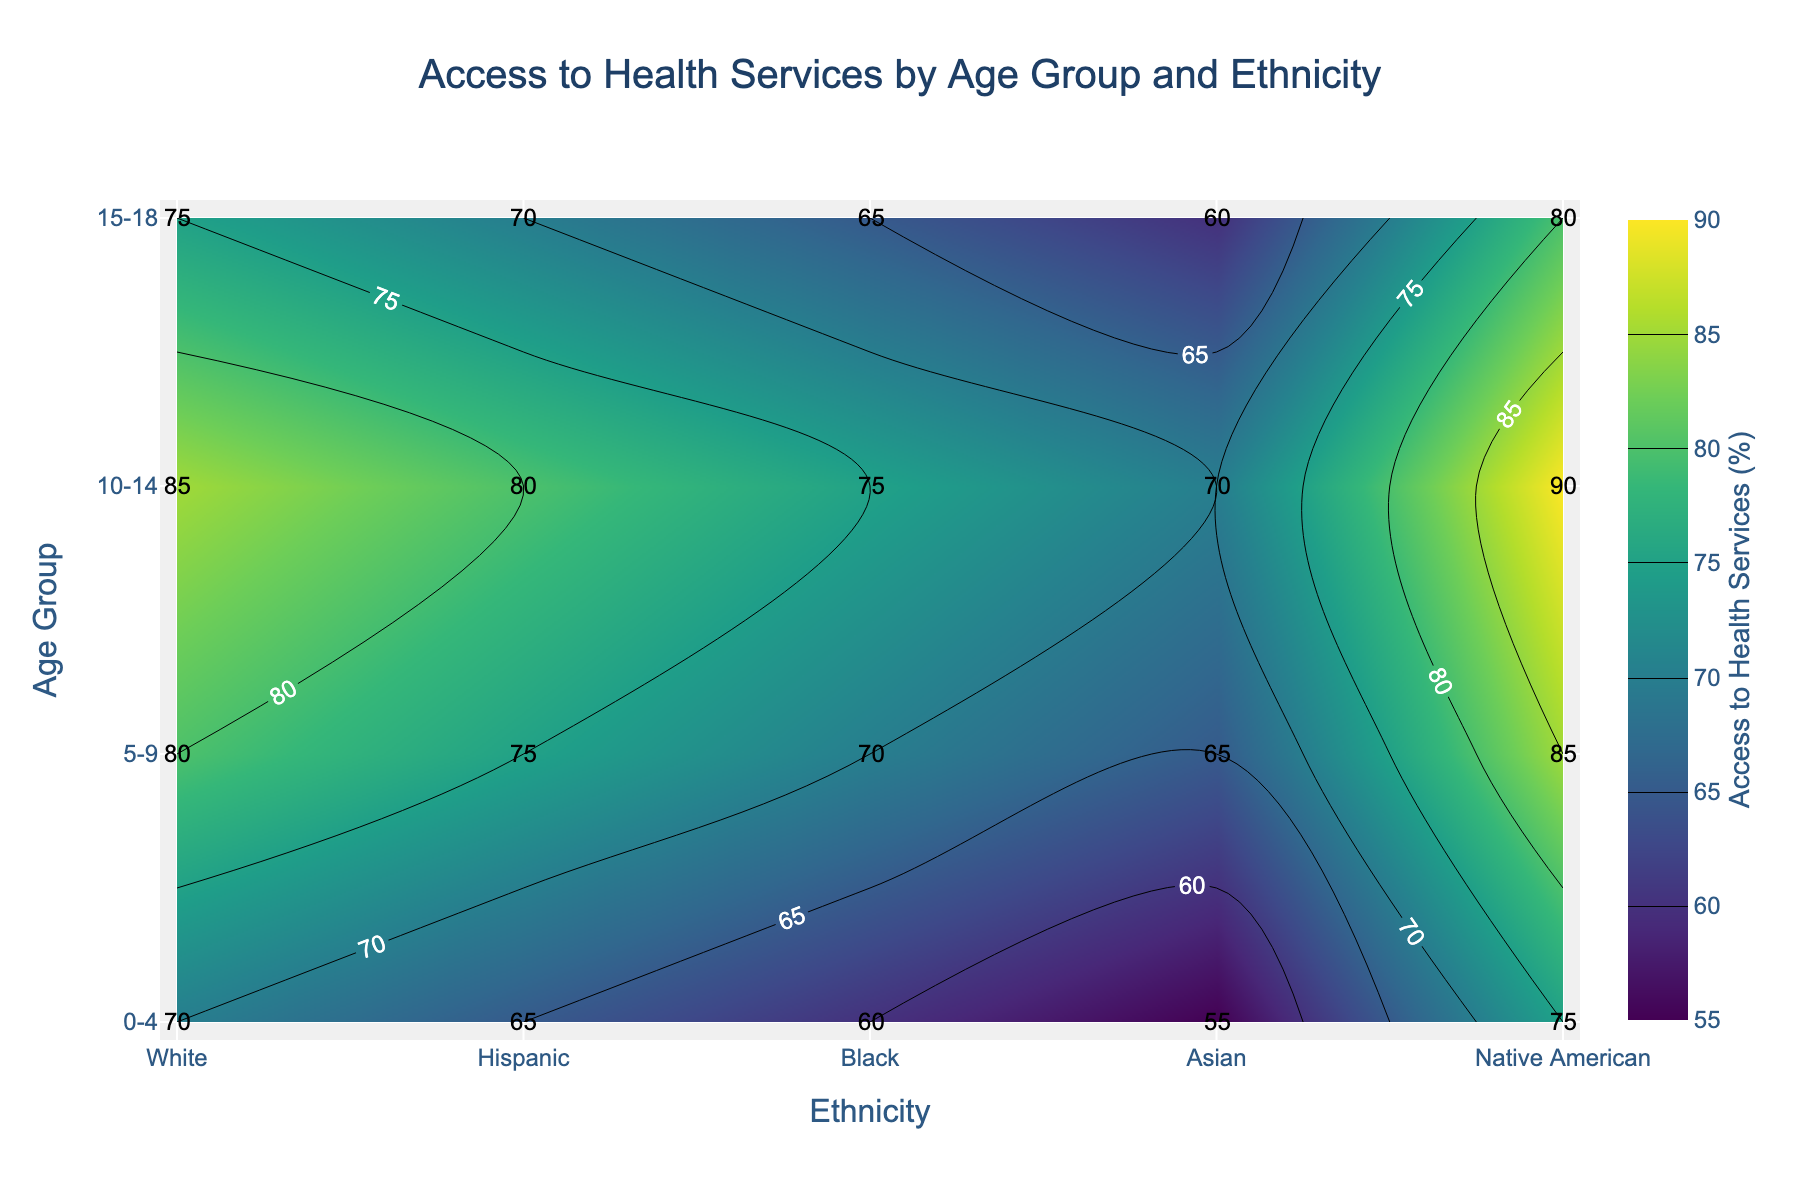What is the title of the contour plot? The title of the plot is usually found at the top center. In this case, the title is "Access to Health Services by Age Group and Ethnicity".
Answer: Access to Health Services by Age Group and Ethnicity Which age group has the highest overall access to health services? By scanning the values within each row, we see that the age group "15-18" consistently has higher values compared to other age groups.
Answer: 15-18 What is the access to health services percentage for Hispanic children aged 10-14? Look at the specific entry where the age group is "10-14" and the ethnicity is "Hispanic". The value given is 70.
Answer: 70 How does the access to health services for Black children aged 5-9 compare to Native American children aged 5-9? Find the values for "Black" and "Native American" under the "5-9" age group. For "Black", it is 70, and for "Native American", it is 60. The access for Black children is higher by 10 points.
Answer: Black children have 10 points higher access Which ethnicity has the lowest access to health services for the "0-4" age group? Identify the values for each ethnicity under "0-4". The lowest value is 55 for "Native American".
Answer: Native American What is the average access to health services for Asian children across all age groups? Sum the values for "Asian" across all age groups (70, 75, 80, 85) and divide by the number of age groups (4). This results in (70 + 75 + 80 + 85) / 4 = 310 / 4 = 77.5.
Answer: 77.5 Which age group shows the greatest disparity in access to health services among different ethnicities, and what are those values? Look for the age group with the highest range between the minimum and maximum values. For "0-4", it’s between 55 and 75 (20 points), for "5-9", it’s between 60 and 80 (20 points), for "10-14", it’s between 65 and 85 (20 points), and for "15-18", it’s between 70 and 90 (20 points). All age groups show the same disparity of 20 points.
Answer: All age groups show the same disparity (20 points) What is the difference in access to health services between White children aged 0-4 and 15-18? Find the values for "White" at "0-4" and "15-18". The values are 75 and 90, respectively. The difference is 90 - 75 = 15.
Answer: 15 What is the median access to health services for all children in the 10-14 age group? List the values: [85, 70, 75, 80, 65]. Order them: [65, 70, 75, 80, 85]. The median is the middle value, which is 75.
Answer: 75 